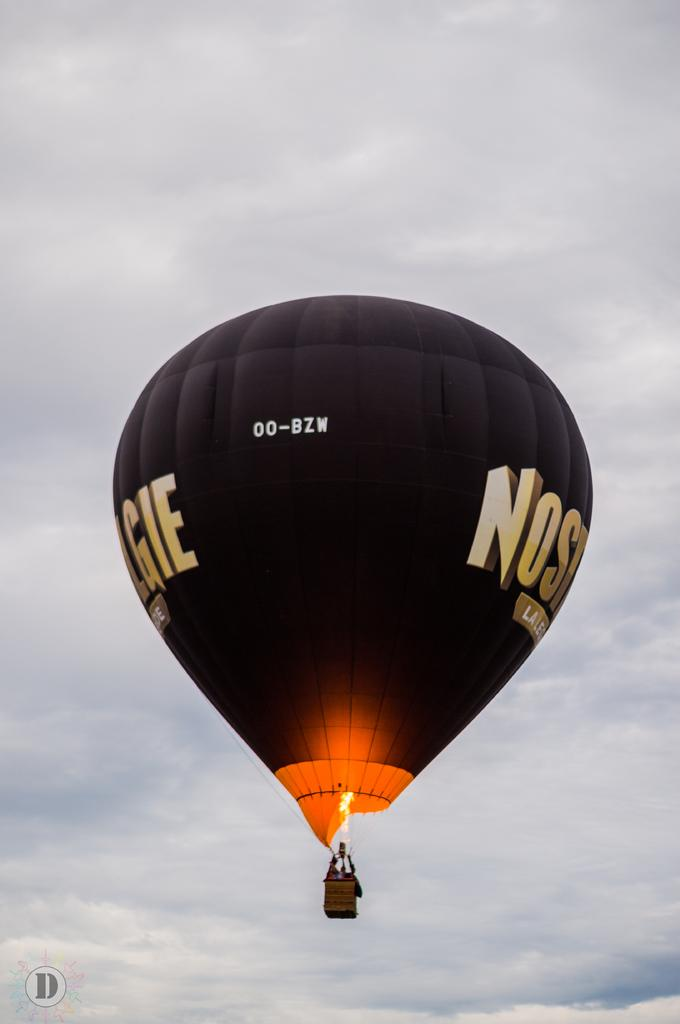<image>
Describe the image concisely. A hot air balloon flying with 00-BZW written on it. 